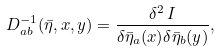Convert formula to latex. <formula><loc_0><loc_0><loc_500><loc_500>D ^ { - 1 } _ { a b } ( \bar { \eta } , x , y ) = \frac { \delta ^ { 2 } \, I } { \delta \bar { \eta } _ { a } ( x ) \delta \bar { \eta } _ { b } ( y ) } ,</formula> 